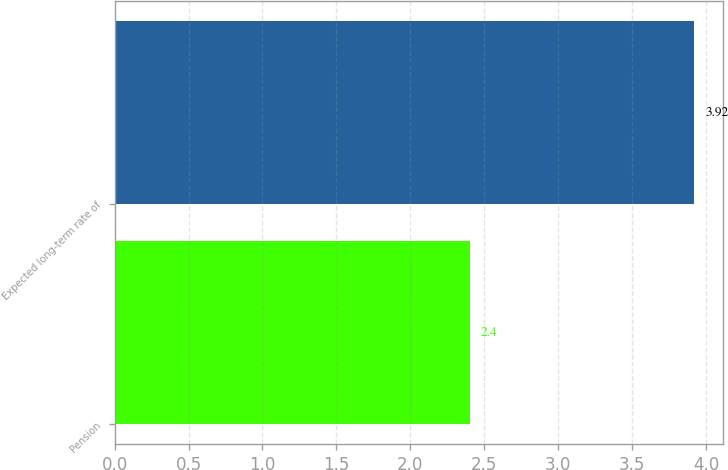Convert chart to OTSL. <chart><loc_0><loc_0><loc_500><loc_500><bar_chart><fcel>Pension<fcel>Expected long-term rate of<nl><fcel>2.4<fcel>3.92<nl></chart> 